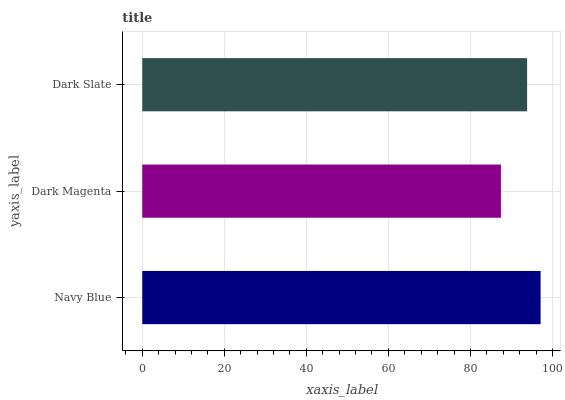Is Dark Magenta the minimum?
Answer yes or no. Yes. Is Navy Blue the maximum?
Answer yes or no. Yes. Is Dark Slate the minimum?
Answer yes or no. No. Is Dark Slate the maximum?
Answer yes or no. No. Is Dark Slate greater than Dark Magenta?
Answer yes or no. Yes. Is Dark Magenta less than Dark Slate?
Answer yes or no. Yes. Is Dark Magenta greater than Dark Slate?
Answer yes or no. No. Is Dark Slate less than Dark Magenta?
Answer yes or no. No. Is Dark Slate the high median?
Answer yes or no. Yes. Is Dark Slate the low median?
Answer yes or no. Yes. Is Dark Magenta the high median?
Answer yes or no. No. Is Navy Blue the low median?
Answer yes or no. No. 